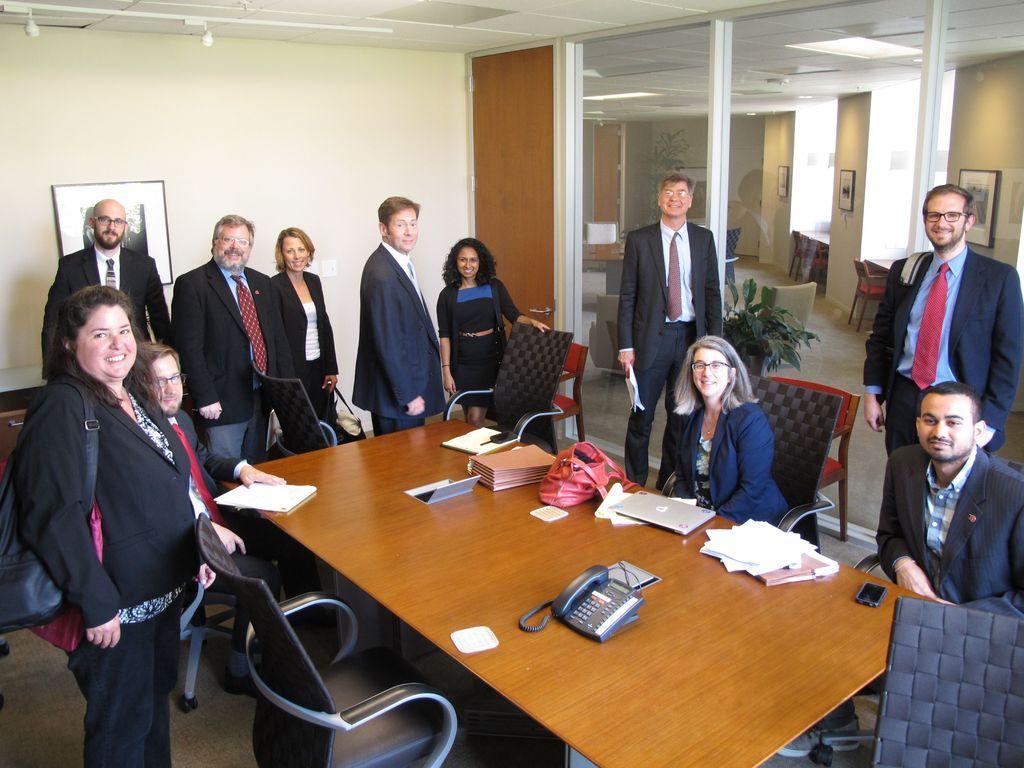Please provide a concise description of this image. Few persons sitting on the chairs and these persons standing. We can see phone,laptop,book,paper on the table. This is floor. On the background we can see wall,frame,glass window. From this glass window we can see plant. 